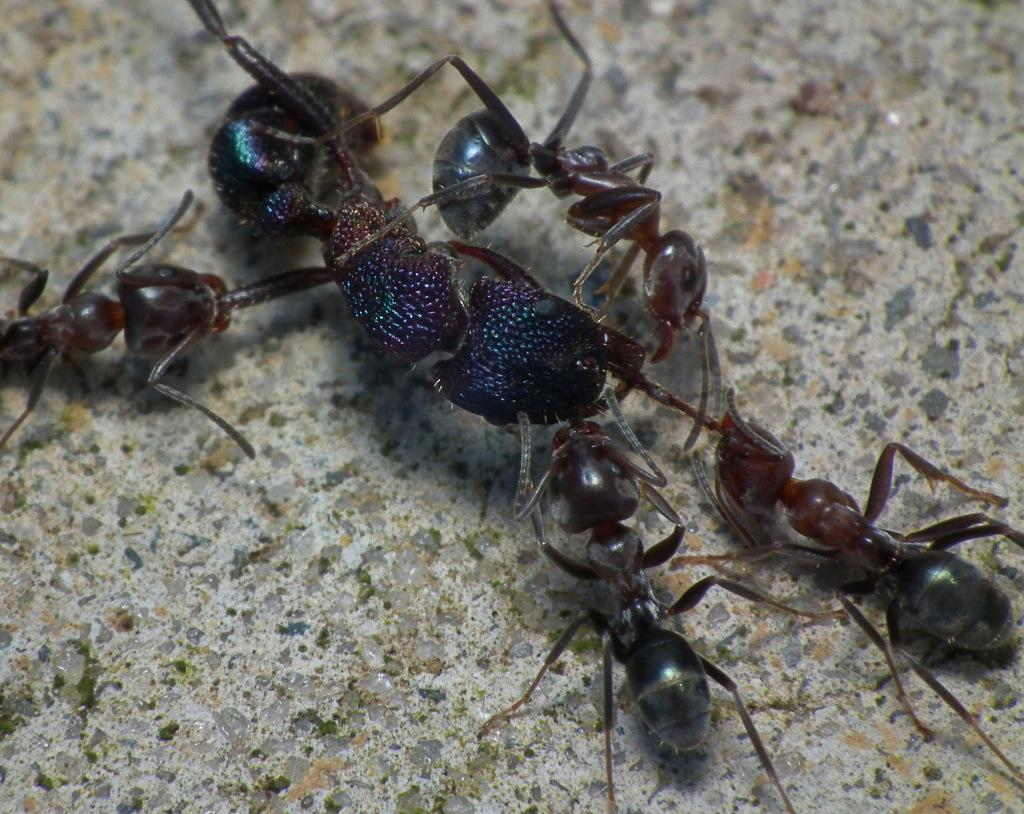What type of insects are present in the image? There are ants in the image. What colors can be seen on the ants? The ants are in black and brown colors. What is the background or surface on which the ants are located? The ants are on a cream-colored surface. How many mice are hiding under the box in the image? There are no mice or boxes present in the image; it only features ants on a cream-colored surface. 